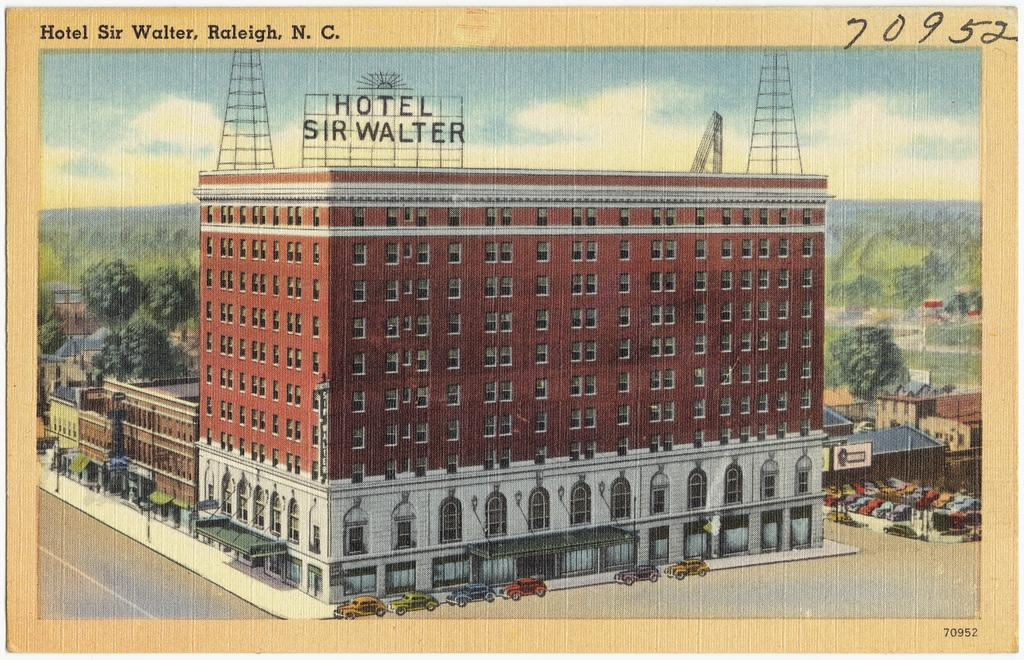What is the main subject of the image? The main subject of the image is a photograph of a building. How is the building in the photograph situated in relation to other buildings? The building in the photograph is beside another building. What can be seen near the buildings in the image? There are cars near the buildings. What type of natural elements are visible in the image? There are trees visible in the image. What else can be seen in the background of the image? There are other buildings in the background of the image. Can you tell me how many farmers are visible in the image? There are no farmers present in the image. What type of clouds can be seen in the image? There is no mention of clouds in the image; only buildings, cars, and trees are visible. 